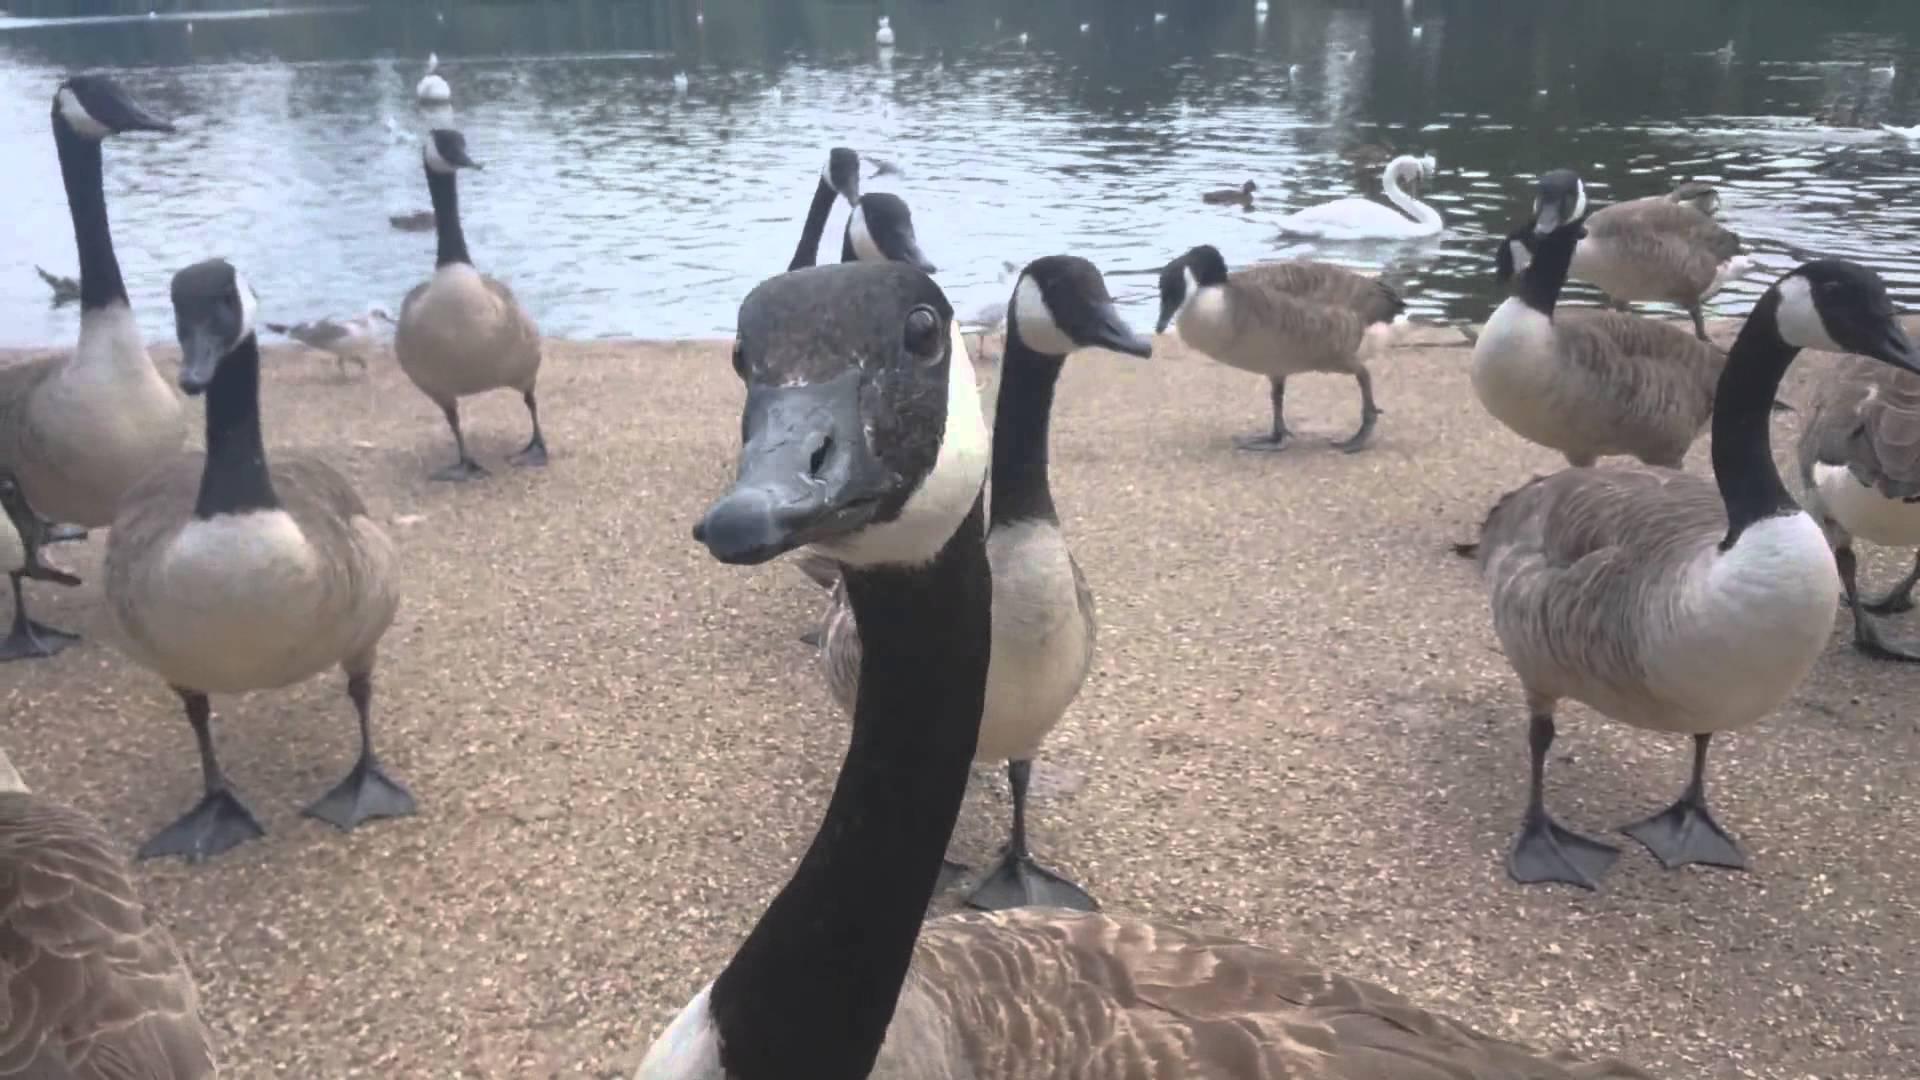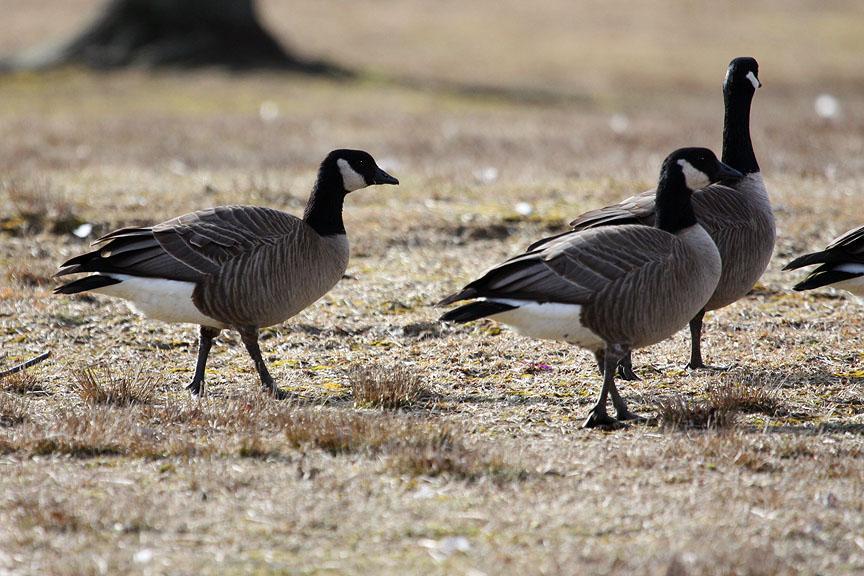The first image is the image on the left, the second image is the image on the right. Analyze the images presented: Is the assertion "in at least one image there are geese eating the grass" valid? Answer yes or no. No. The first image is the image on the left, the second image is the image on the right. Analyze the images presented: Is the assertion "One image has water fowl in the water." valid? Answer yes or no. Yes. 